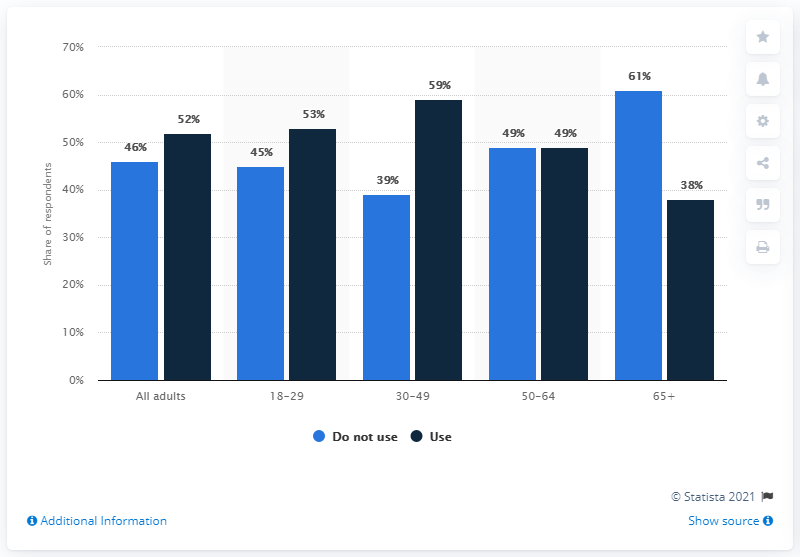Highlight a few significant elements in this photo. The average score for all adults who use and do not use the app is 49. The mode of the graph is 49. 